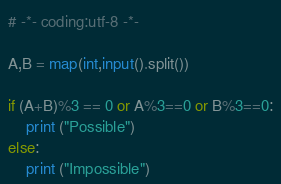Convert code to text. <code><loc_0><loc_0><loc_500><loc_500><_Python_># -*- coding:utf-8 -*-

A,B = map(int,input().split())

if (A+B)%3 == 0 or A%3==0 or B%3==0:
    print ("Possible")
else:
    print ("Impossible")
</code> 